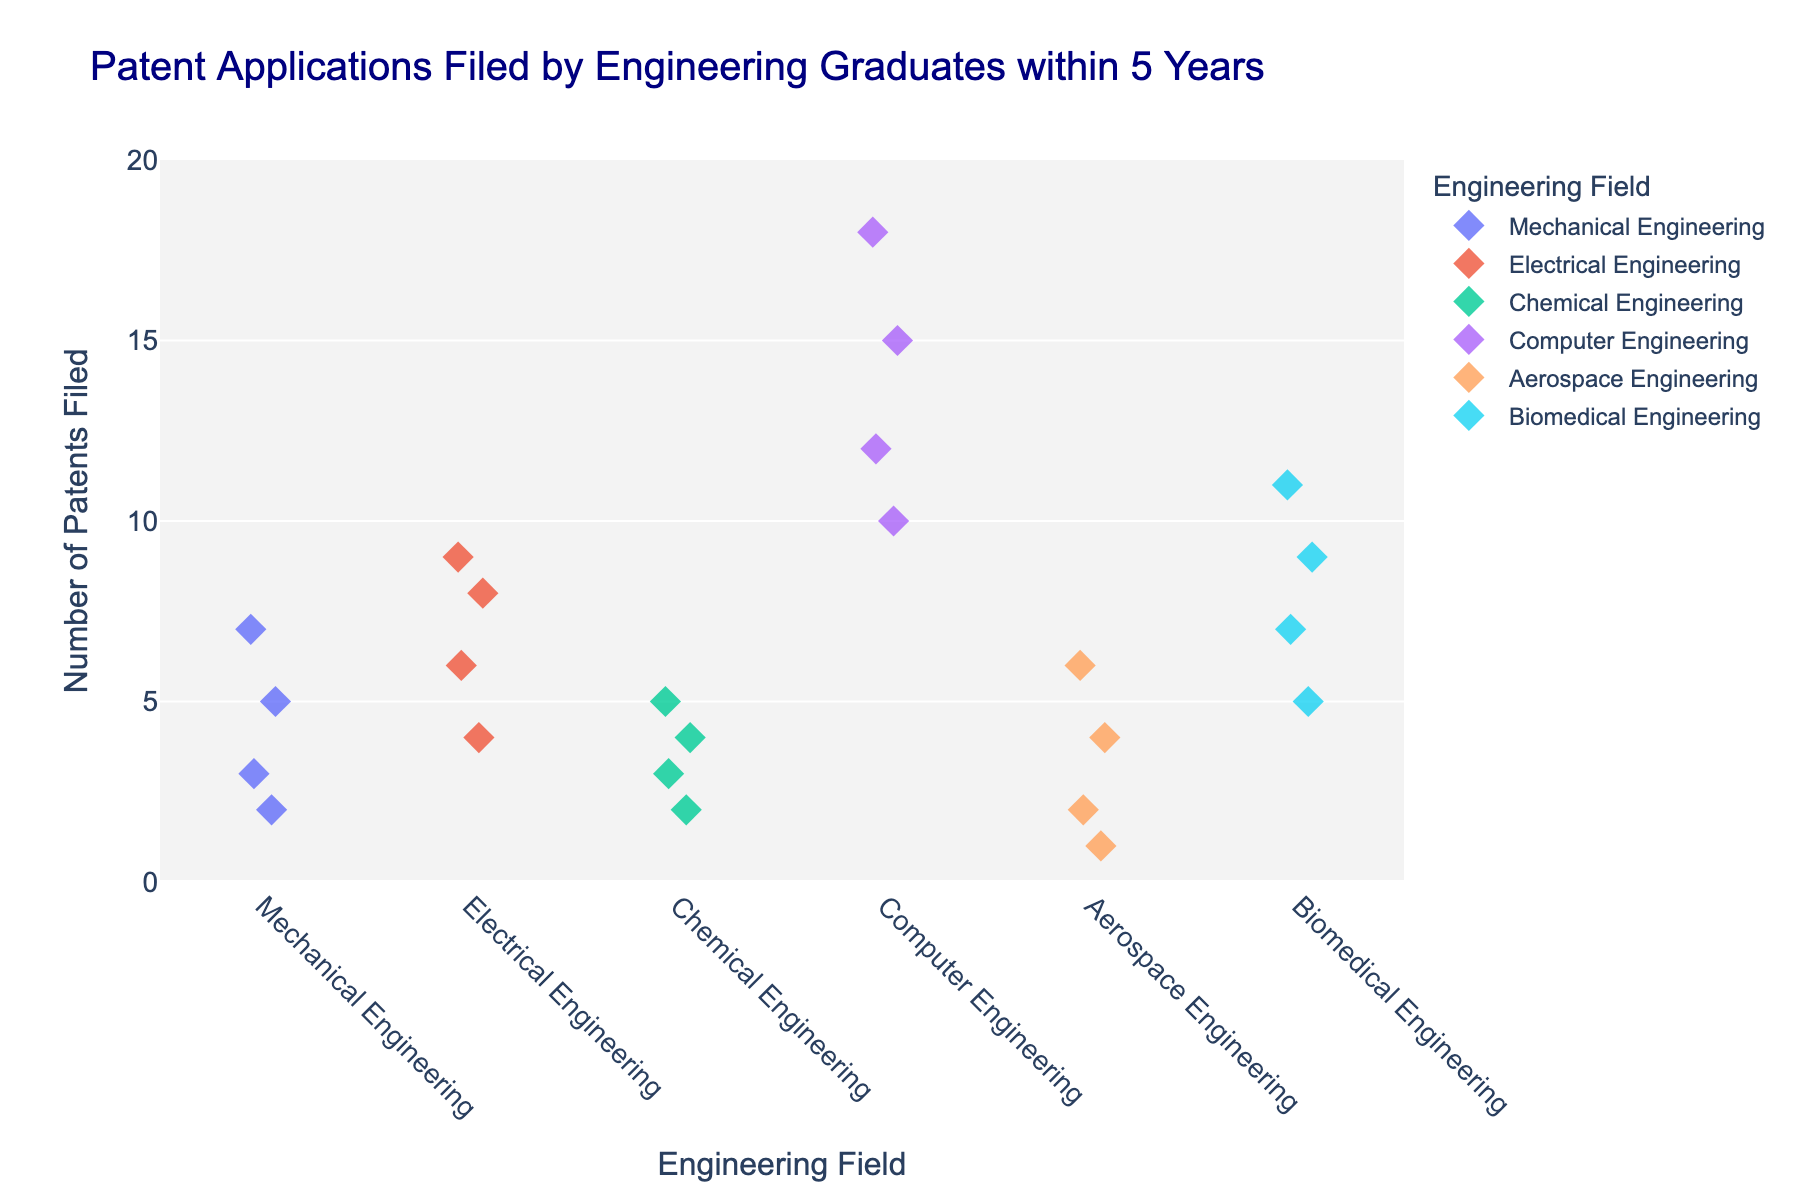what is the title of the plot? The title of the plot is displayed at the top of the figure. It is often a larger and bolder text compared to other elements on the plot. From the information provided, the title is "Patent Applications Filed by Engineering Graduates within 5 Years."
Answer: Patent Applications Filed by Engineering Graduates within 5 Years What does the y-axis represent? The y-axis is labeled to indicate what the data points represent. From the information provided, the y-axis label is "Number of Patents Filed," which means the y-axis represents the number of patents filed by graduates.
Answer: Number of Patents Filed Which engineering field has the highest number of patents filed? To find the field with the highest number of patents filed, look for the engineering field with the data point situated at the highest position on the y-axis. The highest number on the y-axis, as provided, is 18, which corresponds to Computer Engineering.
Answer: Computer Engineering What is the range of patents filed in Mechanical Engineering? To determine the range, one must identify the smallest and largest values for Mechanical Engineering data points. The smallest value provided is 2, and the largest value is 7. Thus, the range is from 2 to 7.
Answer: 2 to 7 Which engineering field has the most data points on the plot? Count the number of data points for each engineering field by identifying the distinct spots along the x-axis for each field. Based on the data provided: Mechanical, Electrical, Chemical, and Biomedical Engineering each have 4 data points, while Computer Engineering and Aerospace Engineering also have 4 data points. Therefore, each field has an equal number of data points.
Answer: Mechanical Engineering (or Electrical, Chemical, Biomedical, Computer, Aerospace Engineering) What is the average number of patents filed by Electrical Engineering graduates? Add the number of patents filed by Electrical Engineering graduates (6, 8, 4, 9) and then divide by the number of data points. The sum is 6 + 8 + 4 + 9 = 27, and there are 4 data points. Hence, the average is 27/4 = 6.75.
Answer: 6.75 Between Mechanical and Biomedical Engineering, which has a higher median number of patents filed? To find the median, list the numbers in ascending order and identify the middle value. For Mechanical Engineering (2, 3, 5, 7), the median is the average of 3 and 5, which is 4. For Biomedical Engineering (5, 7, 9, 11), the median is the average of 7 and 9, which is 8. Thus, Biomedical Engineering has a higher median.
Answer: Biomedical Engineering How many patents were filed in total by Computer Engineering graduates? Sum all the patents filed by Computer Engineering graduates. The data provided are 12, 15, 10, and 18. So, the sum is 12 + 15 + 10 + 18 = 55.
Answer: 55 Is the distribution of patents filed by Aerospace Engineering graduates more even or skewed? Examine the spread and clustering of the data points for Aerospace Engineering. The data points (2, 4, 1, 6) are relatively spread out, without much clustering at one end, suggesting a fairly even distribution.
Answer: Even What field has the fewest patents at the highest end of their range? Identify the highest data point within each field and determine which field has the lowest maximum. For Mechanical (7), Electrical (9), Chemical (5), Computer (18), Aerospace (6), and Biomedical (11). Chemical Engineering has the fewest maximum patents filed with 5.
Answer: Chemical Engineering 